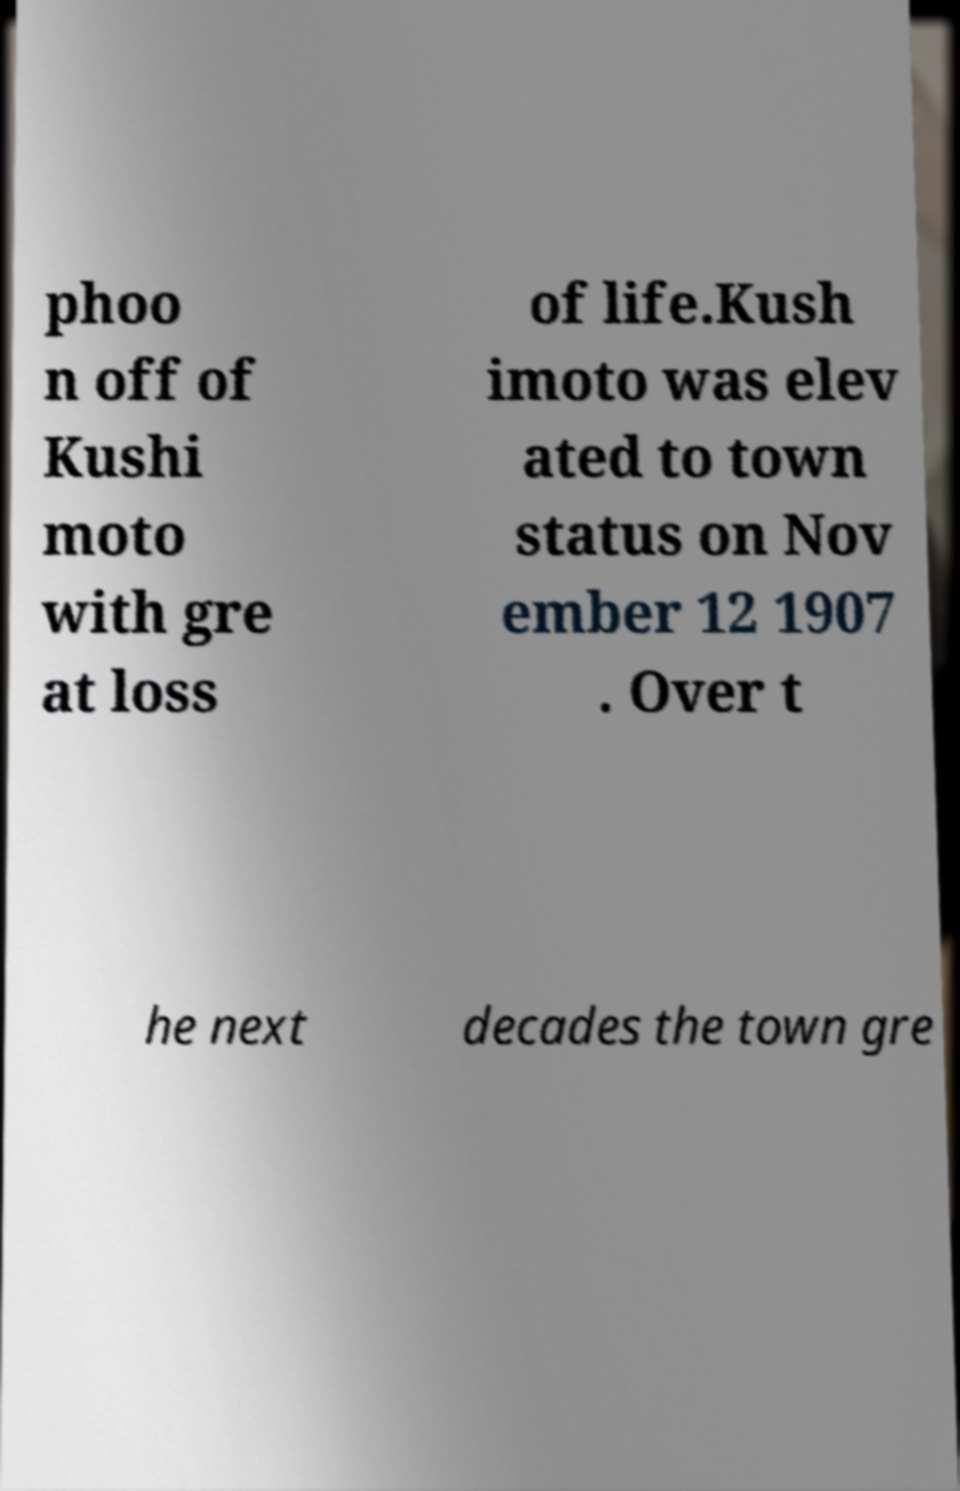Can you read and provide the text displayed in the image?This photo seems to have some interesting text. Can you extract and type it out for me? phoo n off of Kushi moto with gre at loss of life.Kush imoto was elev ated to town status on Nov ember 12 1907 . Over t he next decades the town gre 